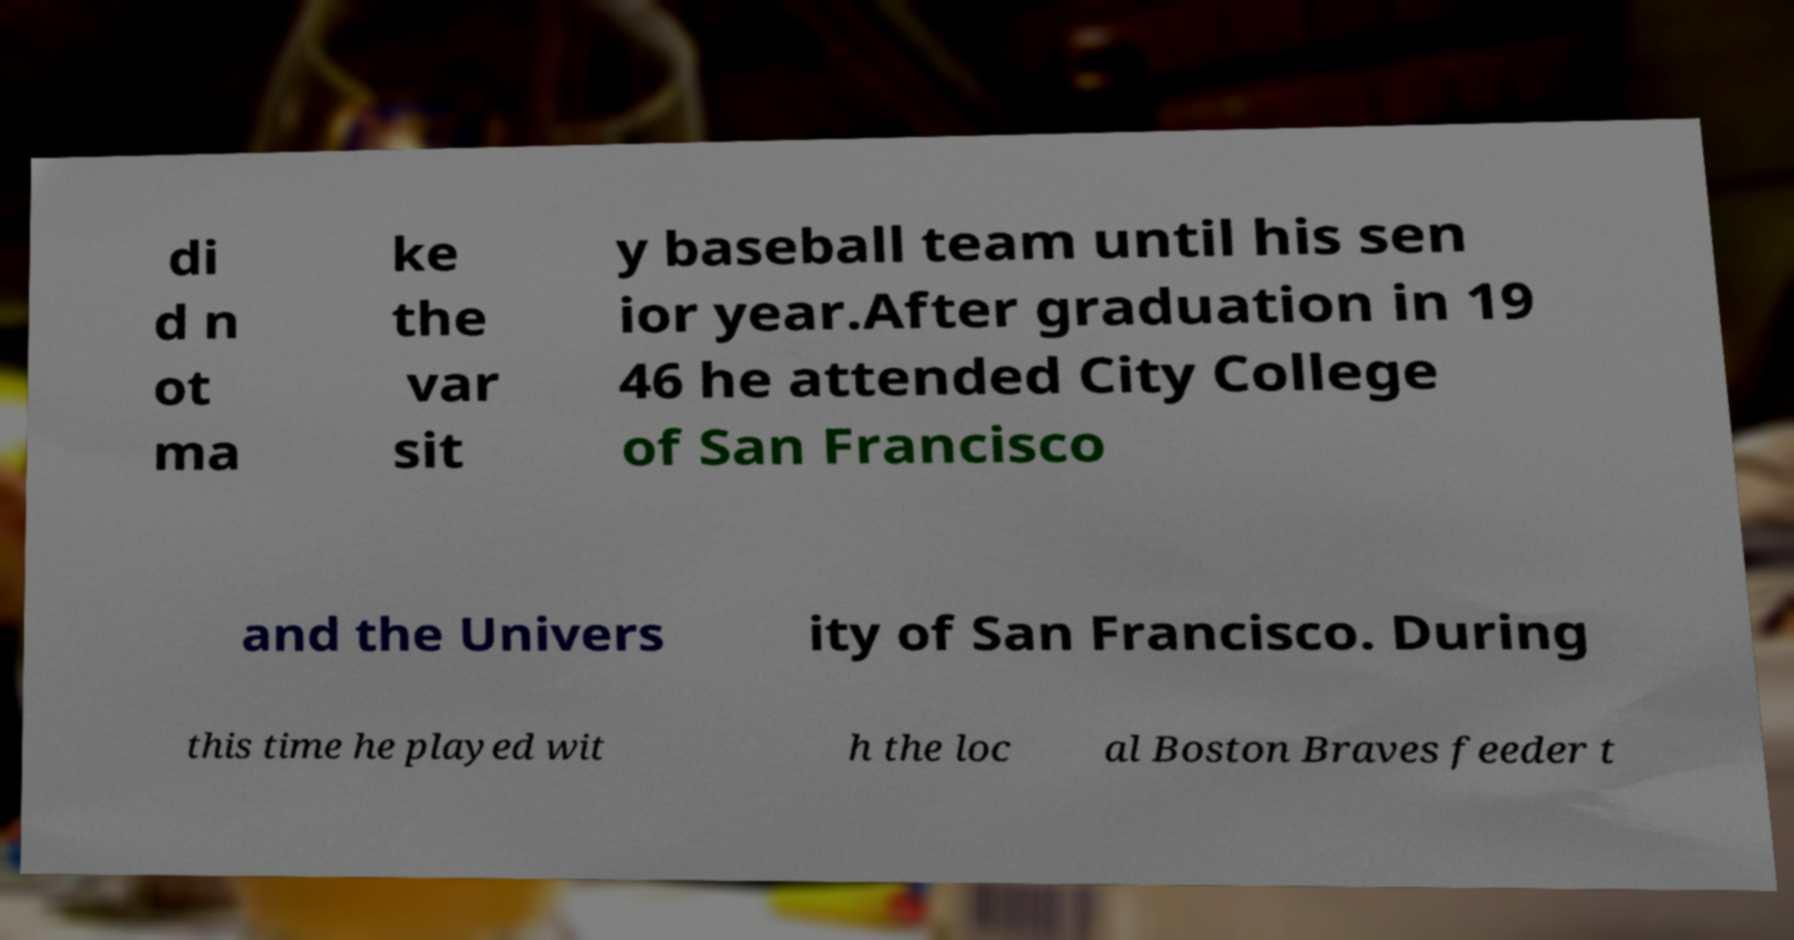For documentation purposes, I need the text within this image transcribed. Could you provide that? di d n ot ma ke the var sit y baseball team until his sen ior year.After graduation in 19 46 he attended City College of San Francisco and the Univers ity of San Francisco. During this time he played wit h the loc al Boston Braves feeder t 